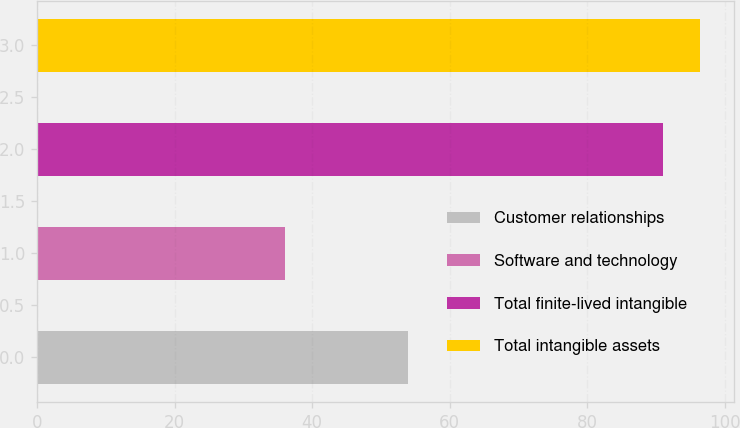Convert chart to OTSL. <chart><loc_0><loc_0><loc_500><loc_500><bar_chart><fcel>Customer relationships<fcel>Software and technology<fcel>Total finite-lived intangible<fcel>Total intangible assets<nl><fcel>54<fcel>36<fcel>91<fcel>96.5<nl></chart> 